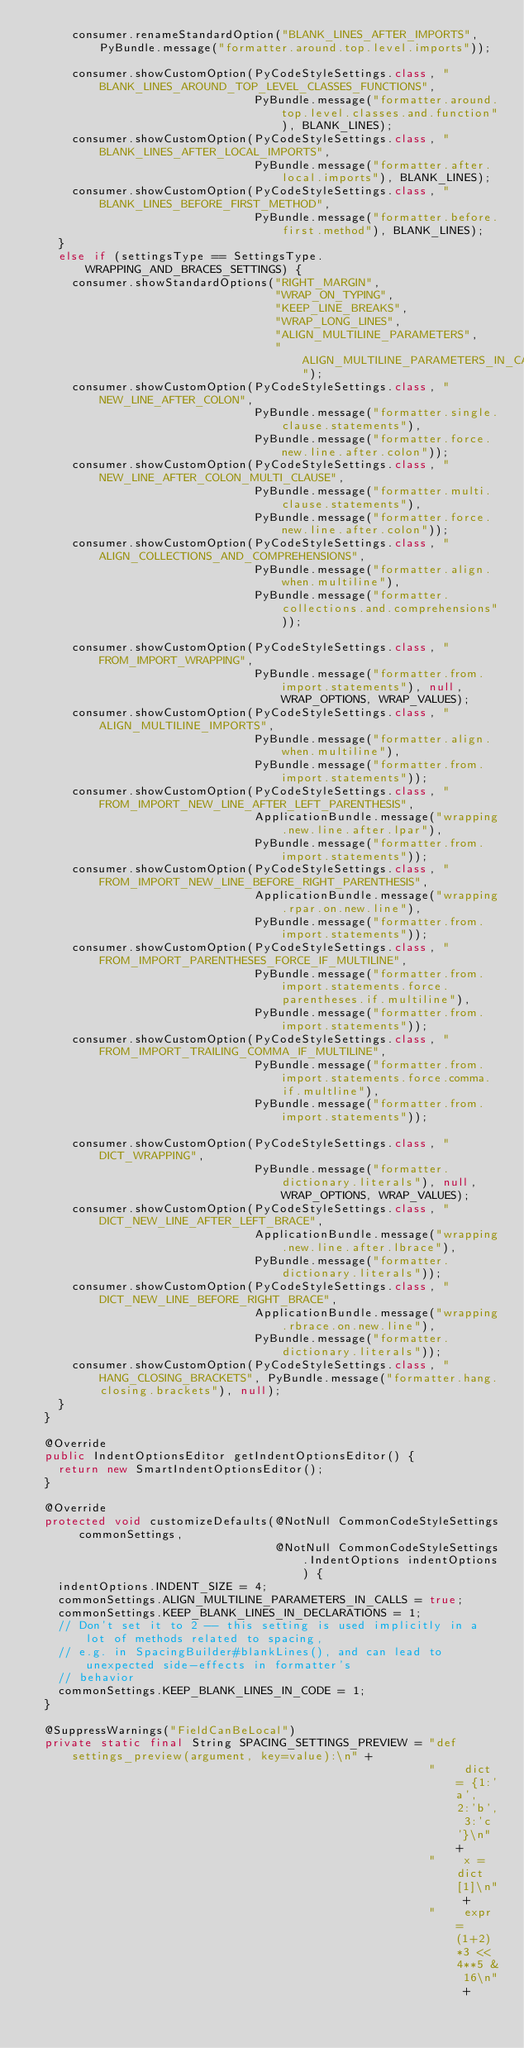<code> <loc_0><loc_0><loc_500><loc_500><_Java_>      consumer.renameStandardOption("BLANK_LINES_AFTER_IMPORTS", PyBundle.message("formatter.around.top.level.imports"));

      consumer.showCustomOption(PyCodeStyleSettings.class, "BLANK_LINES_AROUND_TOP_LEVEL_CLASSES_FUNCTIONS",
                                PyBundle.message("formatter.around.top.level.classes.and.function"), BLANK_LINES);
      consumer.showCustomOption(PyCodeStyleSettings.class, "BLANK_LINES_AFTER_LOCAL_IMPORTS",
                                PyBundle.message("formatter.after.local.imports"), BLANK_LINES);
      consumer.showCustomOption(PyCodeStyleSettings.class, "BLANK_LINES_BEFORE_FIRST_METHOD",
                                PyBundle.message("formatter.before.first.method"), BLANK_LINES);
    }
    else if (settingsType == SettingsType.WRAPPING_AND_BRACES_SETTINGS) {
      consumer.showStandardOptions("RIGHT_MARGIN",
                                   "WRAP_ON_TYPING",
                                   "KEEP_LINE_BREAKS",
                                   "WRAP_LONG_LINES",
                                   "ALIGN_MULTILINE_PARAMETERS",
                                   "ALIGN_MULTILINE_PARAMETERS_IN_CALLS");
      consumer.showCustomOption(PyCodeStyleSettings.class, "NEW_LINE_AFTER_COLON",
                                PyBundle.message("formatter.single.clause.statements"),
                                PyBundle.message("formatter.force.new.line.after.colon"));
      consumer.showCustomOption(PyCodeStyleSettings.class, "NEW_LINE_AFTER_COLON_MULTI_CLAUSE",
                                PyBundle.message("formatter.multi.clause.statements"),
                                PyBundle.message("formatter.force.new.line.after.colon"));
      consumer.showCustomOption(PyCodeStyleSettings.class, "ALIGN_COLLECTIONS_AND_COMPREHENSIONS",
                                PyBundle.message("formatter.align.when.multiline"),
                                PyBundle.message("formatter.collections.and.comprehensions"));
      
      consumer.showCustomOption(PyCodeStyleSettings.class, "FROM_IMPORT_WRAPPING",
                                PyBundle.message("formatter.from.import.statements"), null, WRAP_OPTIONS, WRAP_VALUES);
      consumer.showCustomOption(PyCodeStyleSettings.class, "ALIGN_MULTILINE_IMPORTS",
                                PyBundle.message("formatter.align.when.multiline"),
                                PyBundle.message("formatter.from.import.statements"));
      consumer.showCustomOption(PyCodeStyleSettings.class, "FROM_IMPORT_NEW_LINE_AFTER_LEFT_PARENTHESIS",
                                ApplicationBundle.message("wrapping.new.line.after.lpar"),
                                PyBundle.message("formatter.from.import.statements"));
      consumer.showCustomOption(PyCodeStyleSettings.class, "FROM_IMPORT_NEW_LINE_BEFORE_RIGHT_PARENTHESIS",
                                ApplicationBundle.message("wrapping.rpar.on.new.line"),
                                PyBundle.message("formatter.from.import.statements"));
      consumer.showCustomOption(PyCodeStyleSettings.class, "FROM_IMPORT_PARENTHESES_FORCE_IF_MULTILINE",
                                PyBundle.message("formatter.from.import.statements.force.parentheses.if.multiline"),
                                PyBundle.message("formatter.from.import.statements"));
      consumer.showCustomOption(PyCodeStyleSettings.class, "FROM_IMPORT_TRAILING_COMMA_IF_MULTILINE",
                                PyBundle.message("formatter.from.import.statements.force.comma.if.multline"),
                                PyBundle.message("formatter.from.import.statements"));

      consumer.showCustomOption(PyCodeStyleSettings.class, "DICT_WRAPPING",
                                PyBundle.message("formatter.dictionary.literals"), null, WRAP_OPTIONS, WRAP_VALUES);
      consumer.showCustomOption(PyCodeStyleSettings.class, "DICT_NEW_LINE_AFTER_LEFT_BRACE",
                                ApplicationBundle.message("wrapping.new.line.after.lbrace"),
                                PyBundle.message("formatter.dictionary.literals"));
      consumer.showCustomOption(PyCodeStyleSettings.class, "DICT_NEW_LINE_BEFORE_RIGHT_BRACE",
                                ApplicationBundle.message("wrapping.rbrace.on.new.line"),
                                PyBundle.message("formatter.dictionary.literals"));
      consumer.showCustomOption(PyCodeStyleSettings.class, "HANG_CLOSING_BRACKETS", PyBundle.message("formatter.hang.closing.brackets"), null);
    }
  }

  @Override
  public IndentOptionsEditor getIndentOptionsEditor() {
    return new SmartIndentOptionsEditor();
  }

  @Override
  protected void customizeDefaults(@NotNull CommonCodeStyleSettings commonSettings,
                                   @NotNull CommonCodeStyleSettings.IndentOptions indentOptions) {
    indentOptions.INDENT_SIZE = 4;
    commonSettings.ALIGN_MULTILINE_PARAMETERS_IN_CALLS = true;
    commonSettings.KEEP_BLANK_LINES_IN_DECLARATIONS = 1;
    // Don't set it to 2 -- this setting is used implicitly in a lot of methods related to spacing,
    // e.g. in SpacingBuilder#blankLines(), and can lead to unexpected side-effects in formatter's
    // behavior
    commonSettings.KEEP_BLANK_LINES_IN_CODE = 1;
  }

  @SuppressWarnings("FieldCanBeLocal")
  private static final String SPACING_SETTINGS_PREVIEW = "def settings_preview(argument, key=value):\n" +
                                                         "    dict = {1:'a', 2:'b', 3:'c'}\n" +
                                                         "    x = dict[1]\n" +
                                                         "    expr = (1+2)*3 << 4**5 & 16\n" +</code> 